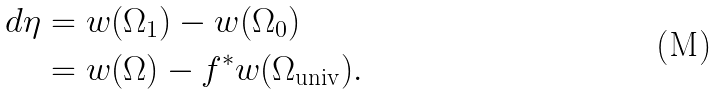Convert formula to latex. <formula><loc_0><loc_0><loc_500><loc_500>d \eta & = w ( \Omega _ { 1 } ) - w ( \Omega _ { 0 } ) \\ & = w ( \Omega ) - f ^ { \ast } w ( \Omega _ { \text {univ} } ) .</formula> 